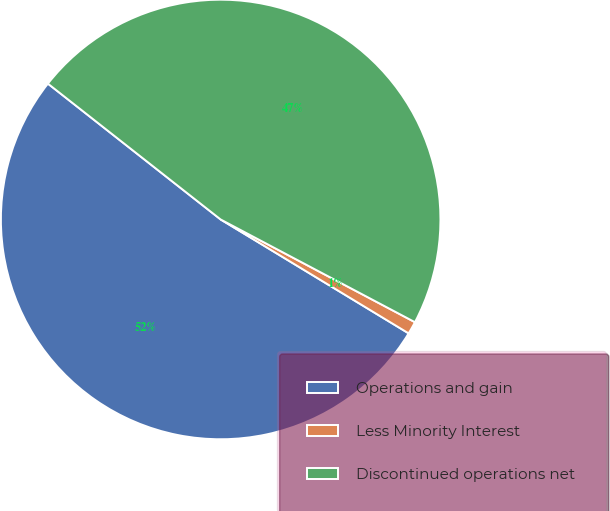Convert chart. <chart><loc_0><loc_0><loc_500><loc_500><pie_chart><fcel>Operations and gain<fcel>Less Minority Interest<fcel>Discontinued operations net<nl><fcel>51.94%<fcel>0.93%<fcel>47.14%<nl></chart> 